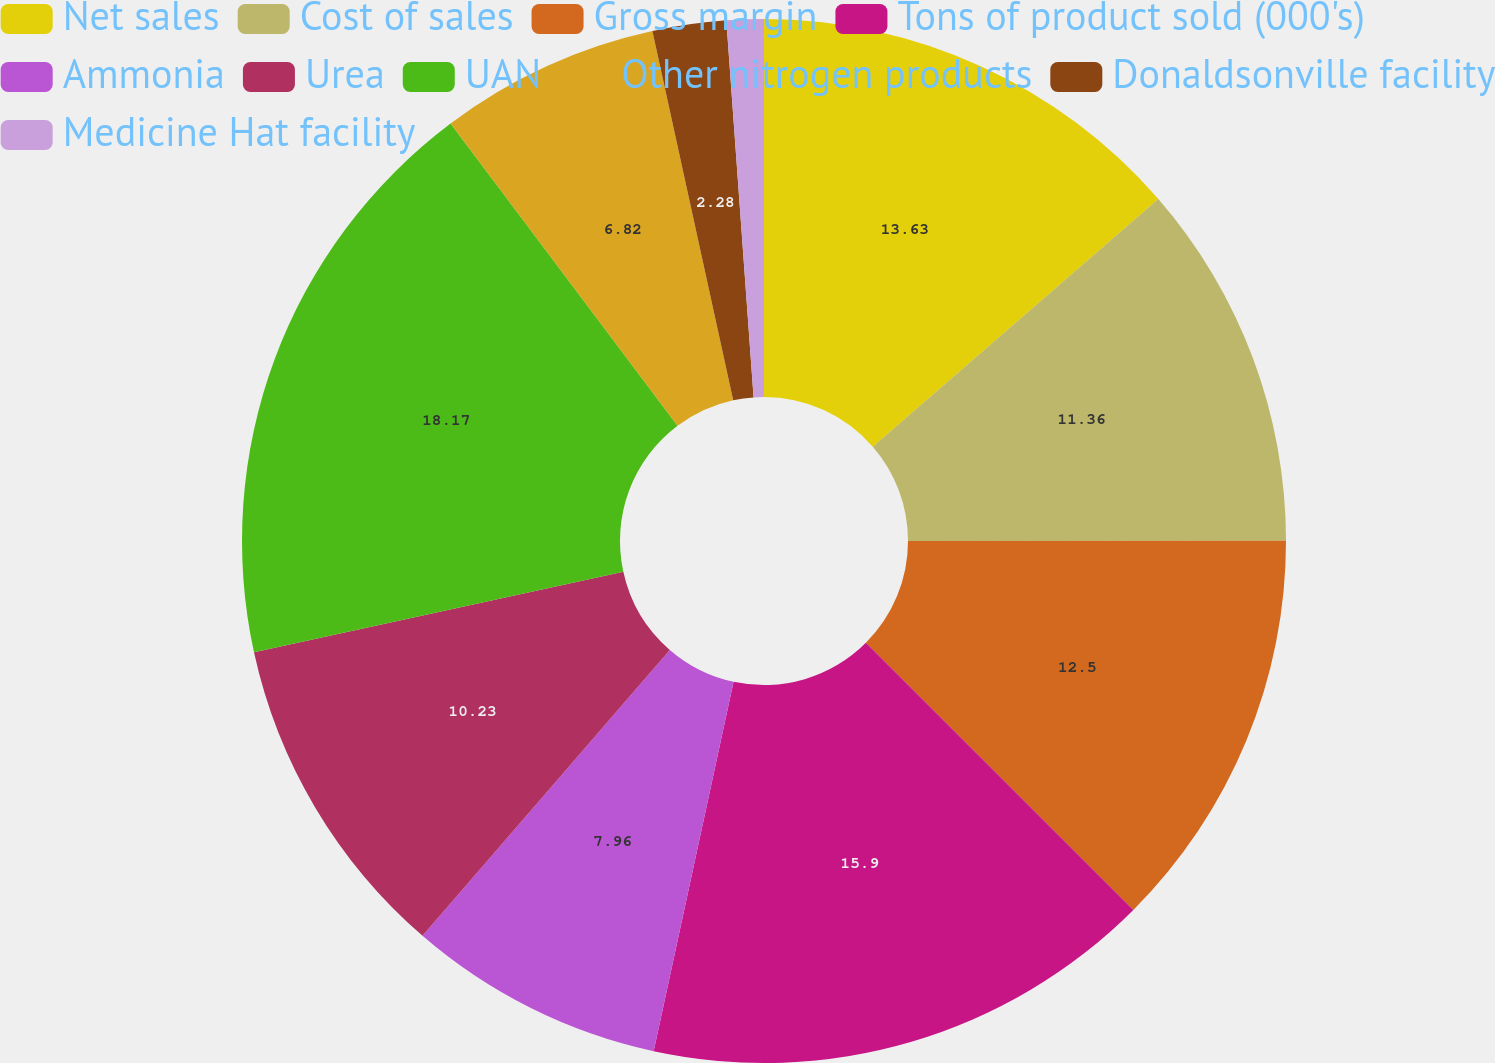Convert chart. <chart><loc_0><loc_0><loc_500><loc_500><pie_chart><fcel>Net sales<fcel>Cost of sales<fcel>Gross margin<fcel>Tons of product sold (000's)<fcel>Ammonia<fcel>Urea<fcel>UAN<fcel>Other nitrogen products<fcel>Donaldsonville facility<fcel>Medicine Hat facility<nl><fcel>13.63%<fcel>11.36%<fcel>12.5%<fcel>15.9%<fcel>7.96%<fcel>10.23%<fcel>18.17%<fcel>6.82%<fcel>2.28%<fcel>1.15%<nl></chart> 